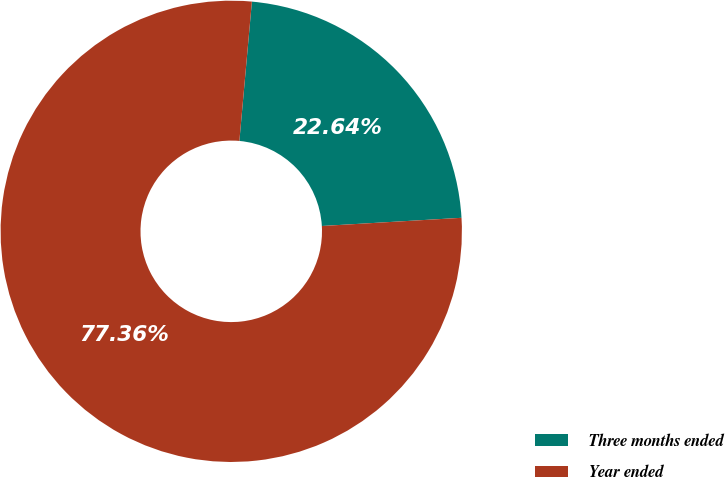Convert chart. <chart><loc_0><loc_0><loc_500><loc_500><pie_chart><fcel>Three months ended<fcel>Year ended<nl><fcel>22.64%<fcel>77.36%<nl></chart> 